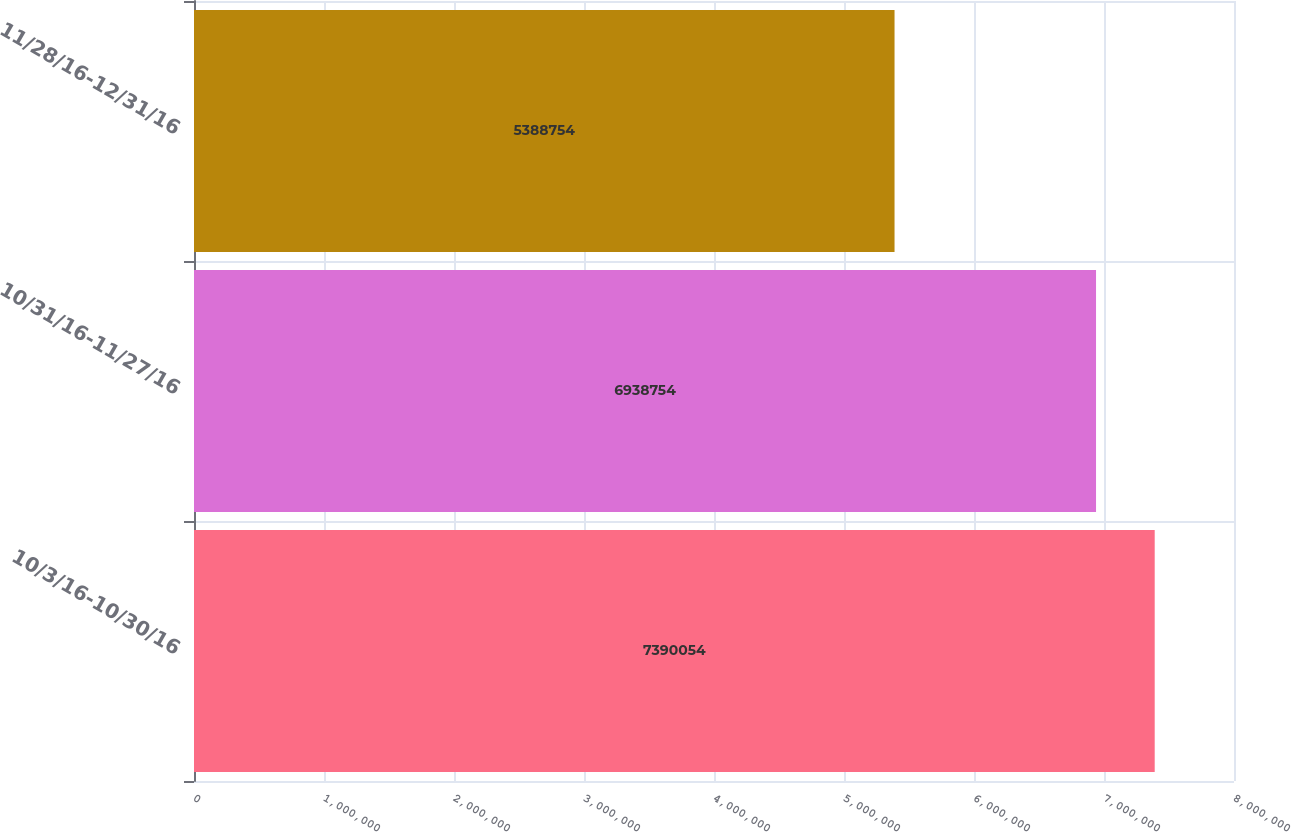Convert chart. <chart><loc_0><loc_0><loc_500><loc_500><bar_chart><fcel>10/3/16-10/30/16<fcel>10/31/16-11/27/16<fcel>11/28/16-12/31/16<nl><fcel>7.39005e+06<fcel>6.93875e+06<fcel>5.38875e+06<nl></chart> 